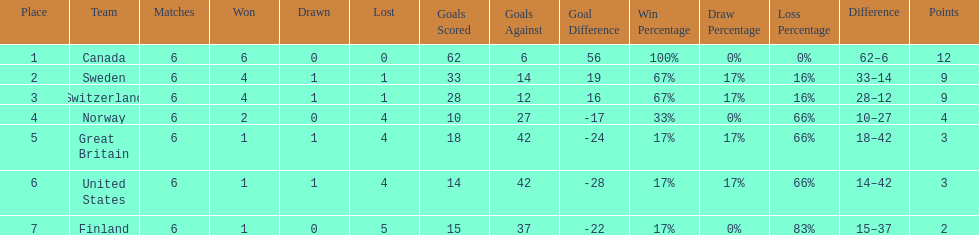What is the total number of teams to have 4 total wins? 2. 